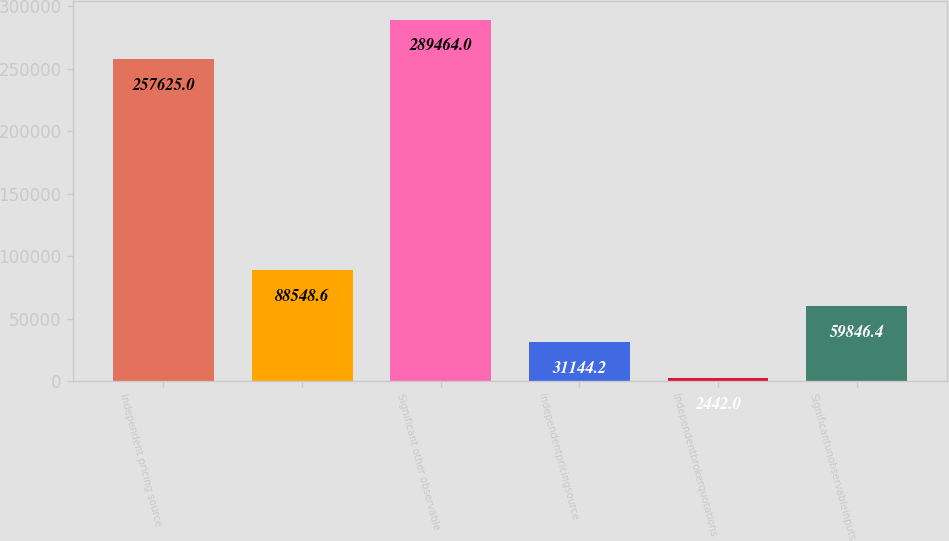Convert chart. <chart><loc_0><loc_0><loc_500><loc_500><bar_chart><fcel>Independent pricing source<fcel>Unnamed: 1<fcel>Significant other observable<fcel>Independentpricingsource<fcel>Independentbrokerquotations<fcel>Significantunobservableinputs<nl><fcel>257625<fcel>88548.6<fcel>289464<fcel>31144.2<fcel>2442<fcel>59846.4<nl></chart> 